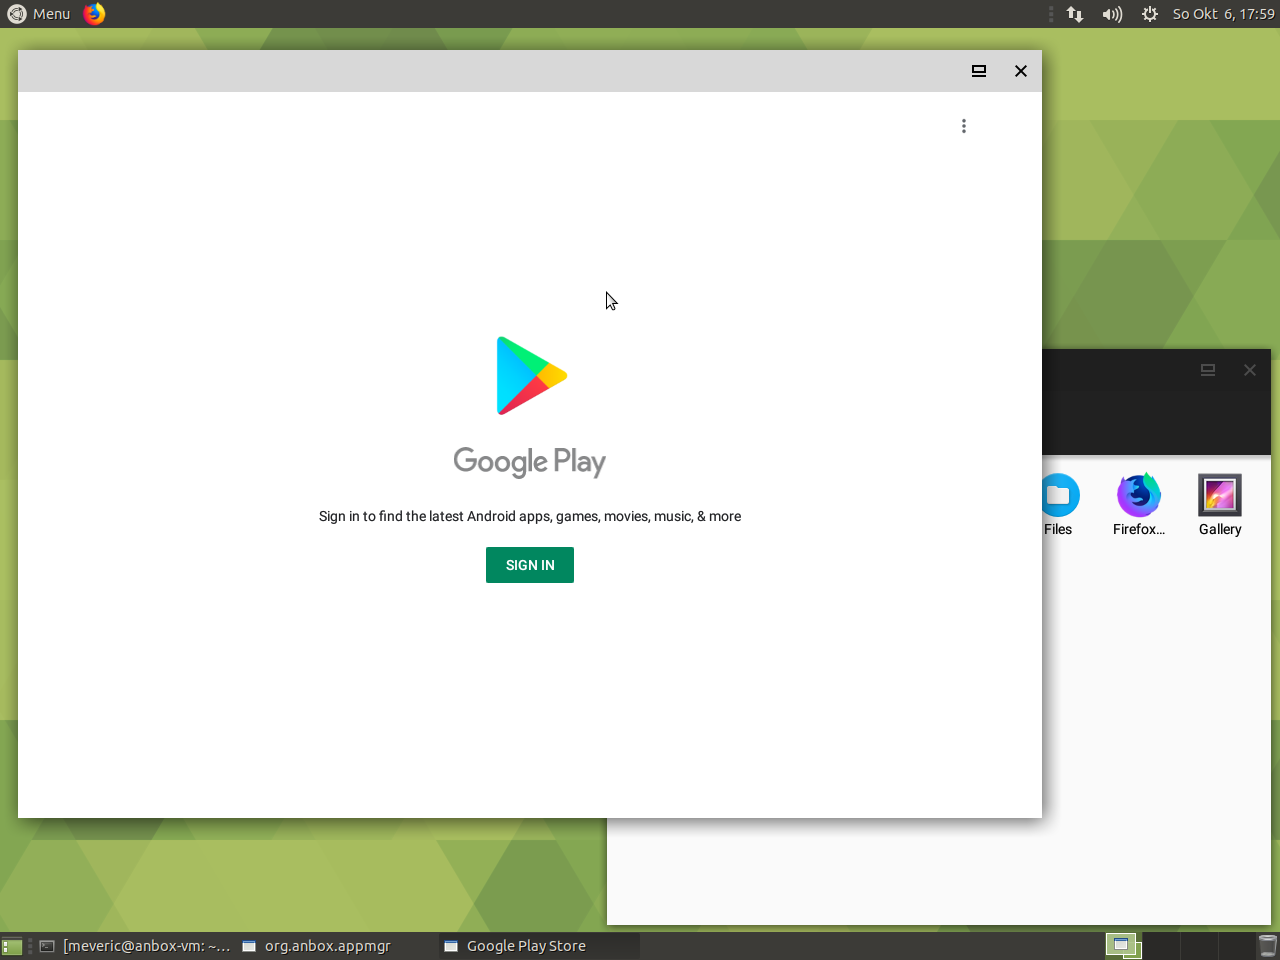What might the battery icon indicate about the current state of the device's power? While the battery icon typically indicates the device's charge level, in this particular image, it does not offer explicit details. From what we can observe, the image shows a desktop interface with various icons and a Google Play window open. As the battery icon is part of an array of status indicators typically found on portable devices like laptops, tablets, or smartphones, it suggests that the device is battery-powered. Given the absence of explicit indicators such as a charging symbol or battery percentage, we cannot ascertain the precise charge level or whether the device is actively charging. Nevertheless, the presence of this icon indicates that the device's power is reliant on a battery, and monitoring this icon will be essential for managing the device's usage to prevent abrupt power loss. 